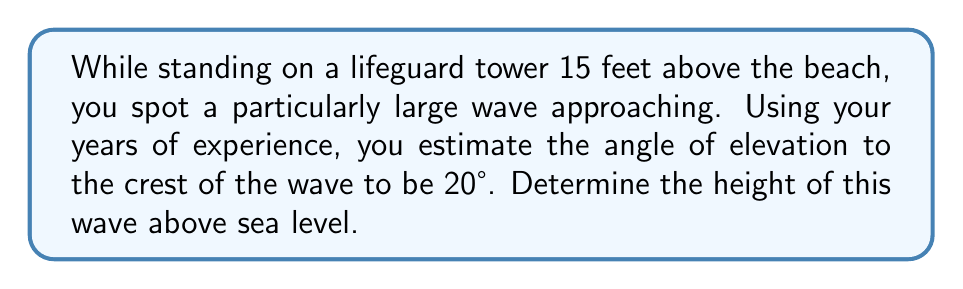Solve this math problem. Let's approach this step-by-step:

1) First, let's visualize the problem:

   [asy]
   import geometry;
   
   size(200);
   
   pair A = (0,0), B = (100,0), C = (100,36.4), D = (0,15);
   
   draw(A--B--C--D--A);
   draw(D--C,dashed);
   
   label("Sea Level", (50,-5));
   label("15 ft", (-5,7.5), W);
   label("Wave", (105,18), E);
   label("20°", (5,15), NW);
   
   dot("Tower", D, NW);
   dot("Wave Crest", C, NE);
   
   markangle(A,D,C,radius=15);
   [/asy]

2) We can use the tangent ratio to solve this problem. The tangent of an angle in a right triangle is the ratio of the opposite side to the adjacent side.

3) In this case:
   - The angle is 20°
   - The adjacent side is the horizontal distance from the tower to the wave (unknown)
   - The opposite side is the difference in height between the wave crest and the tower

4) Let's call the wave height $h$ and the horizontal distance $x$. We can write:

   $$\tan(20°) = \frac{h - 15}{x}$$

5) We don't know $x$, but we don't need to. We can rearrange this equation:

   $$h - 15 = x \tan(20°)$$
   $$h = x \tan(20°) + 15$$

6) Now, we can use the same tangent ratio to find $x$:

   $$\tan(20°) = \frac{15}{x}$$
   $$x = \frac{15}{\tan(20°)}$$

7) Substituting this into our equation for $h$:

   $$h = \frac{15}{\tan(20°)} \tan(20°) + 15$$
   $$h = 15 + 15 = 30$$

Therefore, the wave is 30 feet above sea level.
Answer: 30 feet 